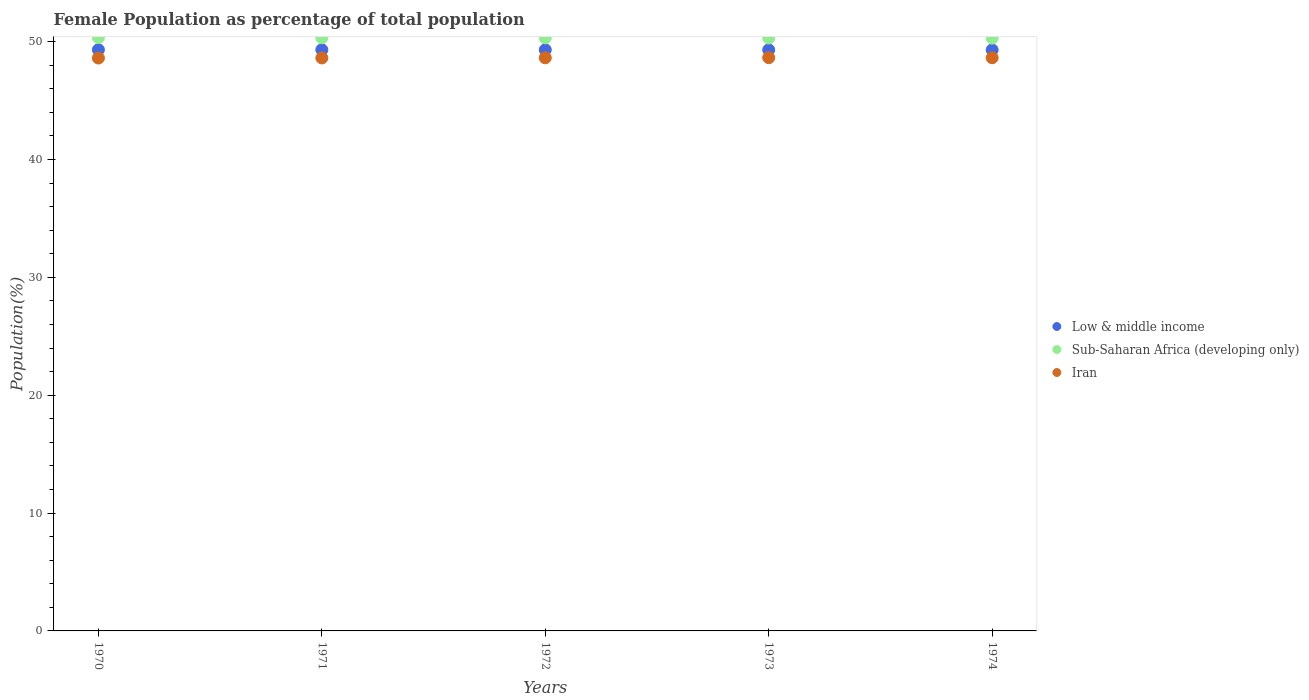How many different coloured dotlines are there?
Your answer should be very brief. 3. Is the number of dotlines equal to the number of legend labels?
Your response must be concise. Yes. What is the female population in in Iran in 1972?
Make the answer very short. 48.63. Across all years, what is the maximum female population in in Low & middle income?
Offer a very short reply. 49.32. Across all years, what is the minimum female population in in Sub-Saharan Africa (developing only)?
Make the answer very short. 50.3. In which year was the female population in in Sub-Saharan Africa (developing only) minimum?
Give a very brief answer. 1974. What is the total female population in in Sub-Saharan Africa (developing only) in the graph?
Keep it short and to the point. 251.62. What is the difference between the female population in in Iran in 1971 and that in 1974?
Your response must be concise. -0.02. What is the difference between the female population in in Sub-Saharan Africa (developing only) in 1971 and the female population in in Low & middle income in 1972?
Offer a terse response. 1.02. What is the average female population in in Sub-Saharan Africa (developing only) per year?
Keep it short and to the point. 50.32. In the year 1974, what is the difference between the female population in in Low & middle income and female population in in Sub-Saharan Africa (developing only)?
Your answer should be compact. -1. What is the ratio of the female population in in Iran in 1971 to that in 1972?
Your answer should be compact. 1. What is the difference between the highest and the second highest female population in in Sub-Saharan Africa (developing only)?
Offer a terse response. 0.01. What is the difference between the highest and the lowest female population in in Iran?
Keep it short and to the point. 0.03. In how many years, is the female population in in Low & middle income greater than the average female population in in Low & middle income taken over all years?
Offer a very short reply. 3. Is the sum of the female population in in Low & middle income in 1970 and 1972 greater than the maximum female population in in Sub-Saharan Africa (developing only) across all years?
Ensure brevity in your answer.  Yes. Is it the case that in every year, the sum of the female population in in Low & middle income and female population in in Sub-Saharan Africa (developing only)  is greater than the female population in in Iran?
Your answer should be very brief. Yes. Is the female population in in Sub-Saharan Africa (developing only) strictly greater than the female population in in Iran over the years?
Give a very brief answer. Yes. How many years are there in the graph?
Provide a short and direct response. 5. What is the difference between two consecutive major ticks on the Y-axis?
Your answer should be compact. 10. Are the values on the major ticks of Y-axis written in scientific E-notation?
Offer a very short reply. No. How many legend labels are there?
Give a very brief answer. 3. How are the legend labels stacked?
Offer a terse response. Vertical. What is the title of the graph?
Offer a very short reply. Female Population as percentage of total population. What is the label or title of the X-axis?
Make the answer very short. Years. What is the label or title of the Y-axis?
Make the answer very short. Population(%). What is the Population(%) of Low & middle income in 1970?
Keep it short and to the point. 49.32. What is the Population(%) of Sub-Saharan Africa (developing only) in 1970?
Your answer should be very brief. 50.35. What is the Population(%) of Iran in 1970?
Make the answer very short. 48.61. What is the Population(%) in Low & middle income in 1971?
Your response must be concise. 49.32. What is the Population(%) of Sub-Saharan Africa (developing only) in 1971?
Your answer should be very brief. 50.34. What is the Population(%) in Iran in 1971?
Keep it short and to the point. 48.62. What is the Population(%) of Low & middle income in 1972?
Your answer should be compact. 49.31. What is the Population(%) in Sub-Saharan Africa (developing only) in 1972?
Keep it short and to the point. 50.32. What is the Population(%) in Iran in 1972?
Provide a succinct answer. 48.63. What is the Population(%) in Low & middle income in 1973?
Your response must be concise. 49.31. What is the Population(%) of Sub-Saharan Africa (developing only) in 1973?
Your answer should be compact. 50.31. What is the Population(%) of Iran in 1973?
Your answer should be compact. 48.64. What is the Population(%) of Low & middle income in 1974?
Provide a short and direct response. 49.3. What is the Population(%) of Sub-Saharan Africa (developing only) in 1974?
Provide a succinct answer. 50.3. What is the Population(%) in Iran in 1974?
Provide a succinct answer. 48.64. Across all years, what is the maximum Population(%) of Low & middle income?
Keep it short and to the point. 49.32. Across all years, what is the maximum Population(%) of Sub-Saharan Africa (developing only)?
Your answer should be compact. 50.35. Across all years, what is the maximum Population(%) of Iran?
Give a very brief answer. 48.64. Across all years, what is the minimum Population(%) of Low & middle income?
Keep it short and to the point. 49.3. Across all years, what is the minimum Population(%) in Sub-Saharan Africa (developing only)?
Make the answer very short. 50.3. Across all years, what is the minimum Population(%) of Iran?
Keep it short and to the point. 48.61. What is the total Population(%) in Low & middle income in the graph?
Ensure brevity in your answer.  246.56. What is the total Population(%) of Sub-Saharan Africa (developing only) in the graph?
Ensure brevity in your answer.  251.62. What is the total Population(%) in Iran in the graph?
Ensure brevity in your answer.  243.15. What is the difference between the Population(%) in Low & middle income in 1970 and that in 1971?
Your answer should be compact. 0. What is the difference between the Population(%) of Sub-Saharan Africa (developing only) in 1970 and that in 1971?
Your response must be concise. 0.01. What is the difference between the Population(%) of Iran in 1970 and that in 1971?
Ensure brevity in your answer.  -0.01. What is the difference between the Population(%) in Low & middle income in 1970 and that in 1972?
Your answer should be very brief. 0.01. What is the difference between the Population(%) in Sub-Saharan Africa (developing only) in 1970 and that in 1972?
Keep it short and to the point. 0.02. What is the difference between the Population(%) in Iran in 1970 and that in 1972?
Your response must be concise. -0.02. What is the difference between the Population(%) of Low & middle income in 1970 and that in 1973?
Your answer should be compact. 0.01. What is the difference between the Population(%) of Sub-Saharan Africa (developing only) in 1970 and that in 1973?
Offer a terse response. 0.03. What is the difference between the Population(%) of Iran in 1970 and that in 1973?
Make the answer very short. -0.03. What is the difference between the Population(%) of Low & middle income in 1970 and that in 1974?
Give a very brief answer. 0.01. What is the difference between the Population(%) in Sub-Saharan Africa (developing only) in 1970 and that in 1974?
Give a very brief answer. 0.05. What is the difference between the Population(%) in Iran in 1970 and that in 1974?
Your answer should be compact. -0.02. What is the difference between the Population(%) of Low & middle income in 1971 and that in 1972?
Give a very brief answer. 0. What is the difference between the Population(%) of Sub-Saharan Africa (developing only) in 1971 and that in 1972?
Your answer should be very brief. 0.01. What is the difference between the Population(%) of Iran in 1971 and that in 1972?
Make the answer very short. -0.01. What is the difference between the Population(%) in Low & middle income in 1971 and that in 1973?
Offer a very short reply. 0.01. What is the difference between the Population(%) of Sub-Saharan Africa (developing only) in 1971 and that in 1973?
Your answer should be very brief. 0.02. What is the difference between the Population(%) in Iran in 1971 and that in 1973?
Give a very brief answer. -0.02. What is the difference between the Population(%) of Low & middle income in 1971 and that in 1974?
Your answer should be compact. 0.01. What is the difference between the Population(%) in Sub-Saharan Africa (developing only) in 1971 and that in 1974?
Provide a short and direct response. 0.03. What is the difference between the Population(%) in Iran in 1971 and that in 1974?
Provide a succinct answer. -0.02. What is the difference between the Population(%) of Low & middle income in 1972 and that in 1973?
Your answer should be compact. 0. What is the difference between the Population(%) in Sub-Saharan Africa (developing only) in 1972 and that in 1973?
Ensure brevity in your answer.  0.01. What is the difference between the Population(%) in Iran in 1972 and that in 1973?
Your answer should be very brief. -0.01. What is the difference between the Population(%) in Low & middle income in 1972 and that in 1974?
Provide a short and direct response. 0.01. What is the difference between the Population(%) of Sub-Saharan Africa (developing only) in 1972 and that in 1974?
Keep it short and to the point. 0.02. What is the difference between the Population(%) of Iran in 1972 and that in 1974?
Your response must be concise. -0. What is the difference between the Population(%) in Low & middle income in 1973 and that in 1974?
Offer a terse response. 0. What is the difference between the Population(%) in Sub-Saharan Africa (developing only) in 1973 and that in 1974?
Ensure brevity in your answer.  0.01. What is the difference between the Population(%) in Iran in 1973 and that in 1974?
Give a very brief answer. 0. What is the difference between the Population(%) in Low & middle income in 1970 and the Population(%) in Sub-Saharan Africa (developing only) in 1971?
Provide a succinct answer. -1.02. What is the difference between the Population(%) of Low & middle income in 1970 and the Population(%) of Iran in 1971?
Your answer should be very brief. 0.7. What is the difference between the Population(%) in Sub-Saharan Africa (developing only) in 1970 and the Population(%) in Iran in 1971?
Make the answer very short. 1.73. What is the difference between the Population(%) in Low & middle income in 1970 and the Population(%) in Sub-Saharan Africa (developing only) in 1972?
Keep it short and to the point. -1. What is the difference between the Population(%) of Low & middle income in 1970 and the Population(%) of Iran in 1972?
Give a very brief answer. 0.69. What is the difference between the Population(%) in Sub-Saharan Africa (developing only) in 1970 and the Population(%) in Iran in 1972?
Ensure brevity in your answer.  1.71. What is the difference between the Population(%) in Low & middle income in 1970 and the Population(%) in Sub-Saharan Africa (developing only) in 1973?
Provide a short and direct response. -0.99. What is the difference between the Population(%) of Low & middle income in 1970 and the Population(%) of Iran in 1973?
Keep it short and to the point. 0.68. What is the difference between the Population(%) in Sub-Saharan Africa (developing only) in 1970 and the Population(%) in Iran in 1973?
Ensure brevity in your answer.  1.71. What is the difference between the Population(%) of Low & middle income in 1970 and the Population(%) of Sub-Saharan Africa (developing only) in 1974?
Provide a short and direct response. -0.98. What is the difference between the Population(%) in Low & middle income in 1970 and the Population(%) in Iran in 1974?
Offer a terse response. 0.68. What is the difference between the Population(%) in Sub-Saharan Africa (developing only) in 1970 and the Population(%) in Iran in 1974?
Provide a succinct answer. 1.71. What is the difference between the Population(%) in Low & middle income in 1971 and the Population(%) in Sub-Saharan Africa (developing only) in 1972?
Provide a short and direct response. -1.01. What is the difference between the Population(%) of Low & middle income in 1971 and the Population(%) of Iran in 1972?
Your answer should be compact. 0.68. What is the difference between the Population(%) of Sub-Saharan Africa (developing only) in 1971 and the Population(%) of Iran in 1972?
Make the answer very short. 1.7. What is the difference between the Population(%) in Low & middle income in 1971 and the Population(%) in Sub-Saharan Africa (developing only) in 1973?
Give a very brief answer. -1. What is the difference between the Population(%) in Low & middle income in 1971 and the Population(%) in Iran in 1973?
Your answer should be very brief. 0.67. What is the difference between the Population(%) in Sub-Saharan Africa (developing only) in 1971 and the Population(%) in Iran in 1973?
Your response must be concise. 1.69. What is the difference between the Population(%) of Low & middle income in 1971 and the Population(%) of Sub-Saharan Africa (developing only) in 1974?
Your answer should be very brief. -0.99. What is the difference between the Population(%) of Low & middle income in 1971 and the Population(%) of Iran in 1974?
Keep it short and to the point. 0.68. What is the difference between the Population(%) of Sub-Saharan Africa (developing only) in 1971 and the Population(%) of Iran in 1974?
Make the answer very short. 1.7. What is the difference between the Population(%) in Low & middle income in 1972 and the Population(%) in Sub-Saharan Africa (developing only) in 1973?
Provide a short and direct response. -1. What is the difference between the Population(%) in Low & middle income in 1972 and the Population(%) in Iran in 1973?
Provide a short and direct response. 0.67. What is the difference between the Population(%) in Sub-Saharan Africa (developing only) in 1972 and the Population(%) in Iran in 1973?
Your answer should be very brief. 1.68. What is the difference between the Population(%) in Low & middle income in 1972 and the Population(%) in Sub-Saharan Africa (developing only) in 1974?
Offer a very short reply. -0.99. What is the difference between the Population(%) in Low & middle income in 1972 and the Population(%) in Iran in 1974?
Ensure brevity in your answer.  0.67. What is the difference between the Population(%) of Sub-Saharan Africa (developing only) in 1972 and the Population(%) of Iran in 1974?
Provide a short and direct response. 1.69. What is the difference between the Population(%) in Low & middle income in 1973 and the Population(%) in Sub-Saharan Africa (developing only) in 1974?
Offer a very short reply. -0.99. What is the difference between the Population(%) in Low & middle income in 1973 and the Population(%) in Iran in 1974?
Offer a very short reply. 0.67. What is the difference between the Population(%) in Sub-Saharan Africa (developing only) in 1973 and the Population(%) in Iran in 1974?
Your response must be concise. 1.68. What is the average Population(%) in Low & middle income per year?
Provide a short and direct response. 49.31. What is the average Population(%) in Sub-Saharan Africa (developing only) per year?
Keep it short and to the point. 50.32. What is the average Population(%) of Iran per year?
Give a very brief answer. 48.63. In the year 1970, what is the difference between the Population(%) of Low & middle income and Population(%) of Sub-Saharan Africa (developing only)?
Provide a short and direct response. -1.03. In the year 1970, what is the difference between the Population(%) of Low & middle income and Population(%) of Iran?
Give a very brief answer. 0.71. In the year 1970, what is the difference between the Population(%) in Sub-Saharan Africa (developing only) and Population(%) in Iran?
Ensure brevity in your answer.  1.73. In the year 1971, what is the difference between the Population(%) of Low & middle income and Population(%) of Sub-Saharan Africa (developing only)?
Your answer should be very brief. -1.02. In the year 1971, what is the difference between the Population(%) of Low & middle income and Population(%) of Iran?
Make the answer very short. 0.69. In the year 1971, what is the difference between the Population(%) in Sub-Saharan Africa (developing only) and Population(%) in Iran?
Offer a very short reply. 1.71. In the year 1972, what is the difference between the Population(%) in Low & middle income and Population(%) in Sub-Saharan Africa (developing only)?
Offer a terse response. -1.01. In the year 1972, what is the difference between the Population(%) in Low & middle income and Population(%) in Iran?
Provide a short and direct response. 0.68. In the year 1972, what is the difference between the Population(%) of Sub-Saharan Africa (developing only) and Population(%) of Iran?
Your answer should be very brief. 1.69. In the year 1973, what is the difference between the Population(%) of Low & middle income and Population(%) of Sub-Saharan Africa (developing only)?
Offer a very short reply. -1. In the year 1973, what is the difference between the Population(%) in Low & middle income and Population(%) in Iran?
Your answer should be very brief. 0.67. In the year 1973, what is the difference between the Population(%) of Sub-Saharan Africa (developing only) and Population(%) of Iran?
Give a very brief answer. 1.67. In the year 1974, what is the difference between the Population(%) of Low & middle income and Population(%) of Sub-Saharan Africa (developing only)?
Your response must be concise. -1. In the year 1974, what is the difference between the Population(%) in Low & middle income and Population(%) in Iran?
Ensure brevity in your answer.  0.67. In the year 1974, what is the difference between the Population(%) in Sub-Saharan Africa (developing only) and Population(%) in Iran?
Make the answer very short. 1.66. What is the ratio of the Population(%) of Low & middle income in 1970 to that in 1971?
Your response must be concise. 1. What is the ratio of the Population(%) in Iran in 1970 to that in 1971?
Provide a succinct answer. 1. What is the ratio of the Population(%) in Sub-Saharan Africa (developing only) in 1970 to that in 1972?
Offer a very short reply. 1. What is the ratio of the Population(%) in Low & middle income in 1970 to that in 1974?
Your answer should be very brief. 1. What is the ratio of the Population(%) of Iran in 1970 to that in 1974?
Offer a very short reply. 1. What is the ratio of the Population(%) in Low & middle income in 1971 to that in 1972?
Offer a very short reply. 1. What is the ratio of the Population(%) in Sub-Saharan Africa (developing only) in 1971 to that in 1972?
Provide a short and direct response. 1. What is the ratio of the Population(%) in Sub-Saharan Africa (developing only) in 1971 to that in 1973?
Give a very brief answer. 1. What is the ratio of the Population(%) of Low & middle income in 1971 to that in 1974?
Offer a very short reply. 1. What is the ratio of the Population(%) in Sub-Saharan Africa (developing only) in 1971 to that in 1974?
Your answer should be very brief. 1. What is the ratio of the Population(%) in Iran in 1971 to that in 1974?
Give a very brief answer. 1. What is the ratio of the Population(%) of Low & middle income in 1972 to that in 1973?
Offer a very short reply. 1. What is the ratio of the Population(%) of Iran in 1972 to that in 1973?
Ensure brevity in your answer.  1. What is the ratio of the Population(%) of Low & middle income in 1972 to that in 1974?
Offer a terse response. 1. What is the ratio of the Population(%) of Sub-Saharan Africa (developing only) in 1972 to that in 1974?
Provide a short and direct response. 1. What is the ratio of the Population(%) in Iran in 1972 to that in 1974?
Provide a short and direct response. 1. What is the ratio of the Population(%) in Iran in 1973 to that in 1974?
Your answer should be very brief. 1. What is the difference between the highest and the second highest Population(%) of Low & middle income?
Provide a succinct answer. 0. What is the difference between the highest and the second highest Population(%) of Sub-Saharan Africa (developing only)?
Give a very brief answer. 0.01. What is the difference between the highest and the second highest Population(%) in Iran?
Your answer should be compact. 0. What is the difference between the highest and the lowest Population(%) in Low & middle income?
Make the answer very short. 0.01. What is the difference between the highest and the lowest Population(%) of Sub-Saharan Africa (developing only)?
Your answer should be very brief. 0.05. What is the difference between the highest and the lowest Population(%) in Iran?
Give a very brief answer. 0.03. 